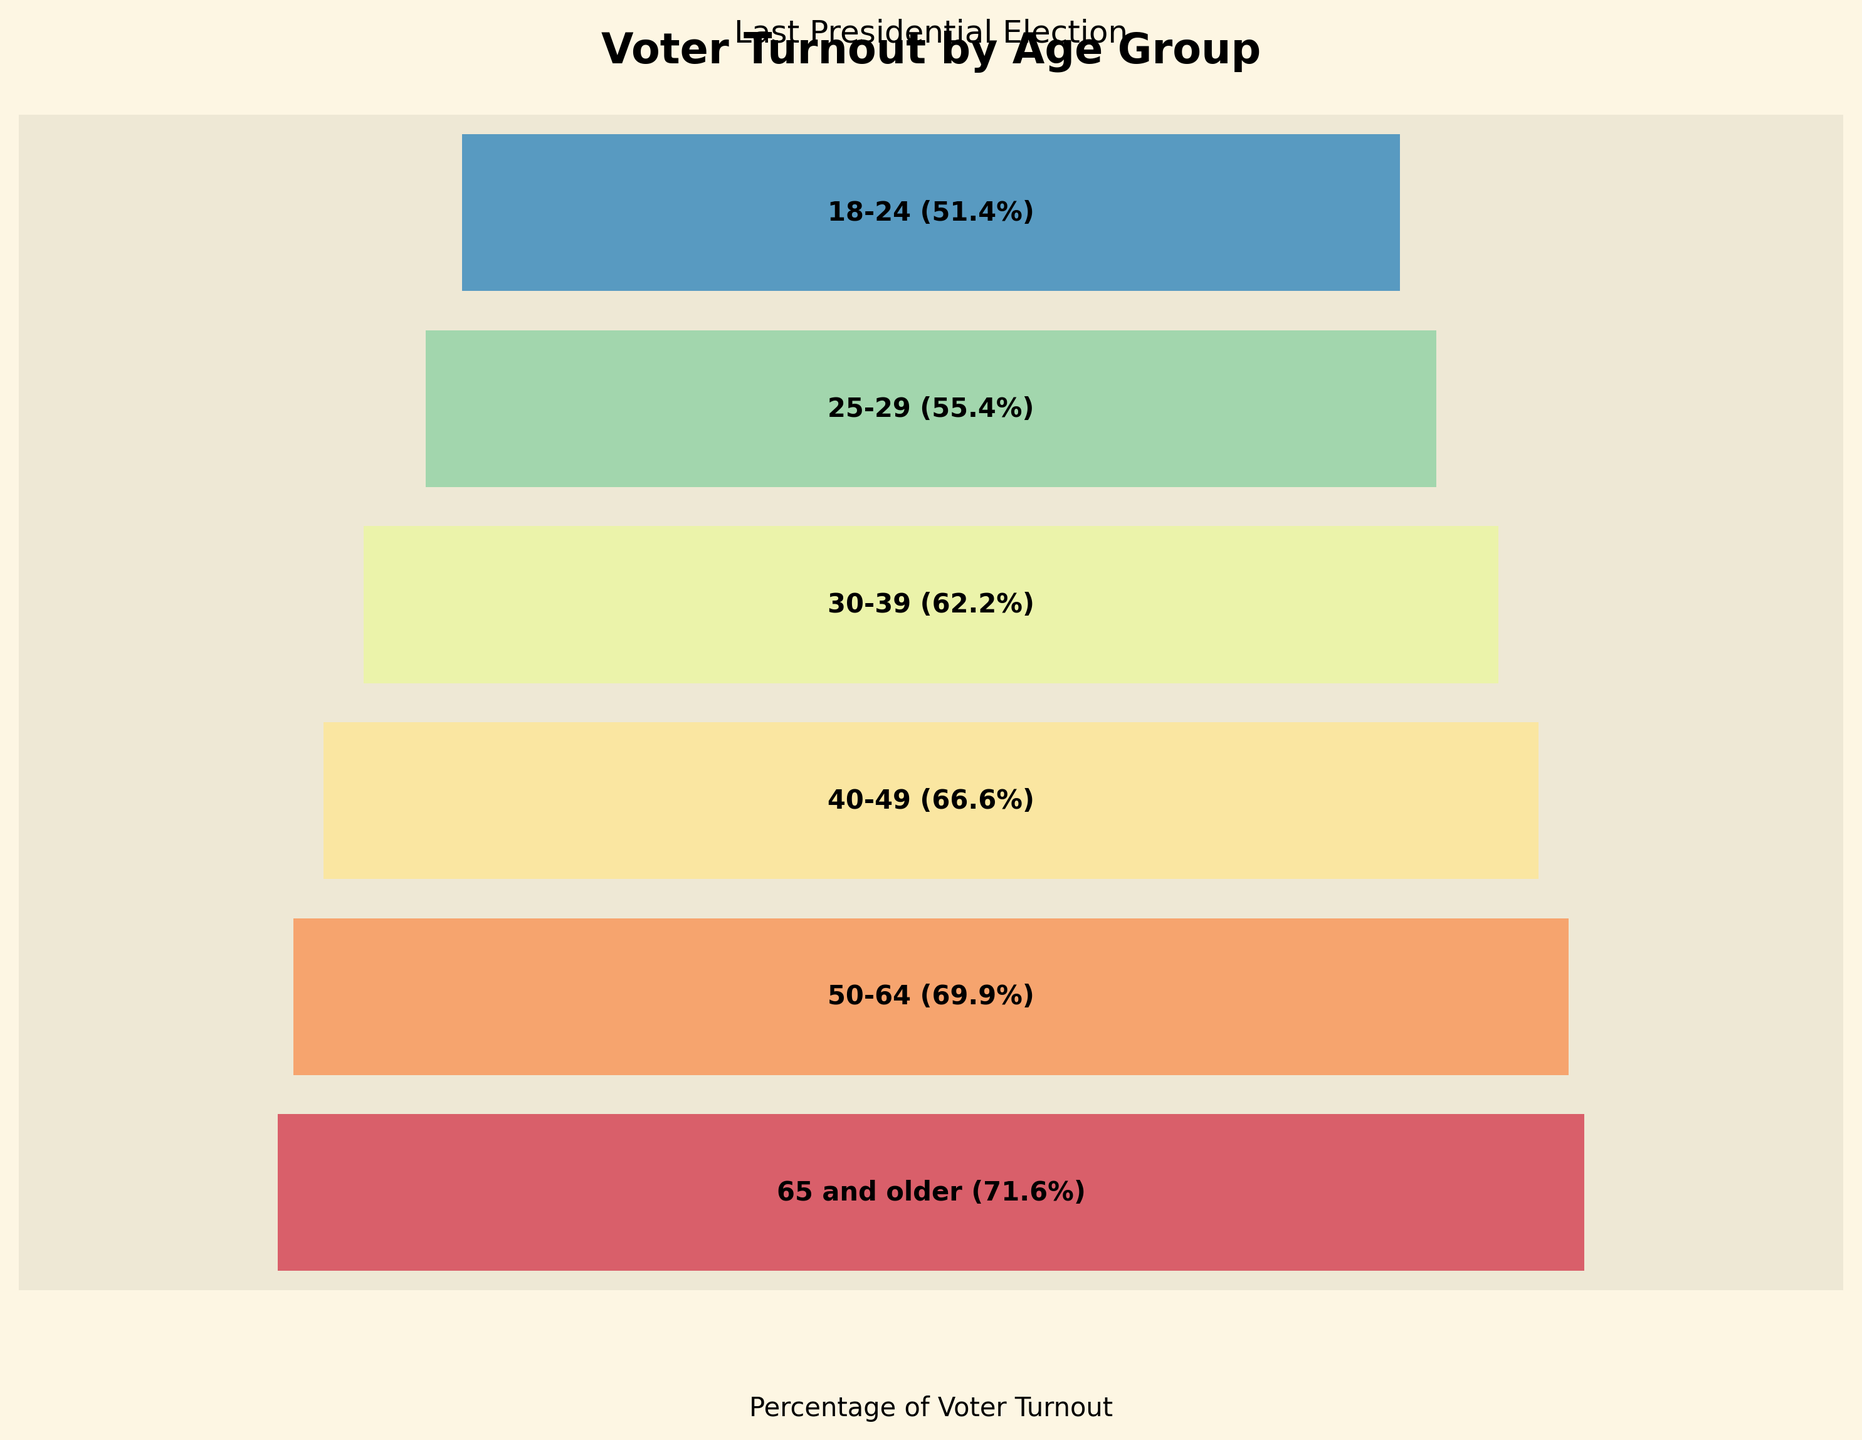How many age groups are displayed in the figure? Count the number of distinct age groups listed on the chart.
Answer: 6 Which age group has the highest voter turnout rate? Identify the age group with the highest percentage bar in the chart and check its label for the voter turnout percentage.
Answer: 65 and older What is the difference in voter turnout between the age group 30-39 and the age group 18-24? Locate the voter turnout percentages for the age groups 30-39 and 18-24 in the chart. Subtract the percentage of 18-24 from that of 30-39.
Answer: 10.8% What is the average voter turnout percentage for all the age groups combined? Add up the voter turnout percentages for all age groups and then divide by the number of age groups. (71.6 + 69.9 + 66.6 + 62.2 + 55.4 + 51.4) / 6 = 62.85
Answer: 62.85% Is the voter turnout for the age group 50-64 higher than the age group 40-49? Compare the voter turnout percentages for the age groups 50-64 and 40-49. The percentage for 50-64 is 69.9% and for 40-49 is 66.6%.
Answer: Yes Which age group has the lowest voter turnout rate? Identify the age group with the lowest percentage bar in the chart and check its label for the voter turnout percentage.
Answer: 18-24 By how many percentage points does the voter turnout of the age group 65 and older exceed the age group 25-29? Locate the voter turnout percentages for the age groups 65 and older and 25-29 in the chart. Subtract the percentage of 25-29 from that of 65 and older.
Answer: 16.2% What pattern can be observed in the voter turnout rates as age increases from 18-24 to 65 and older? Review the progression of voter turnout rates across the age groups from younger to older. Observe that the percentages increase as age increases.
Answer: Voter turnout increases with age 